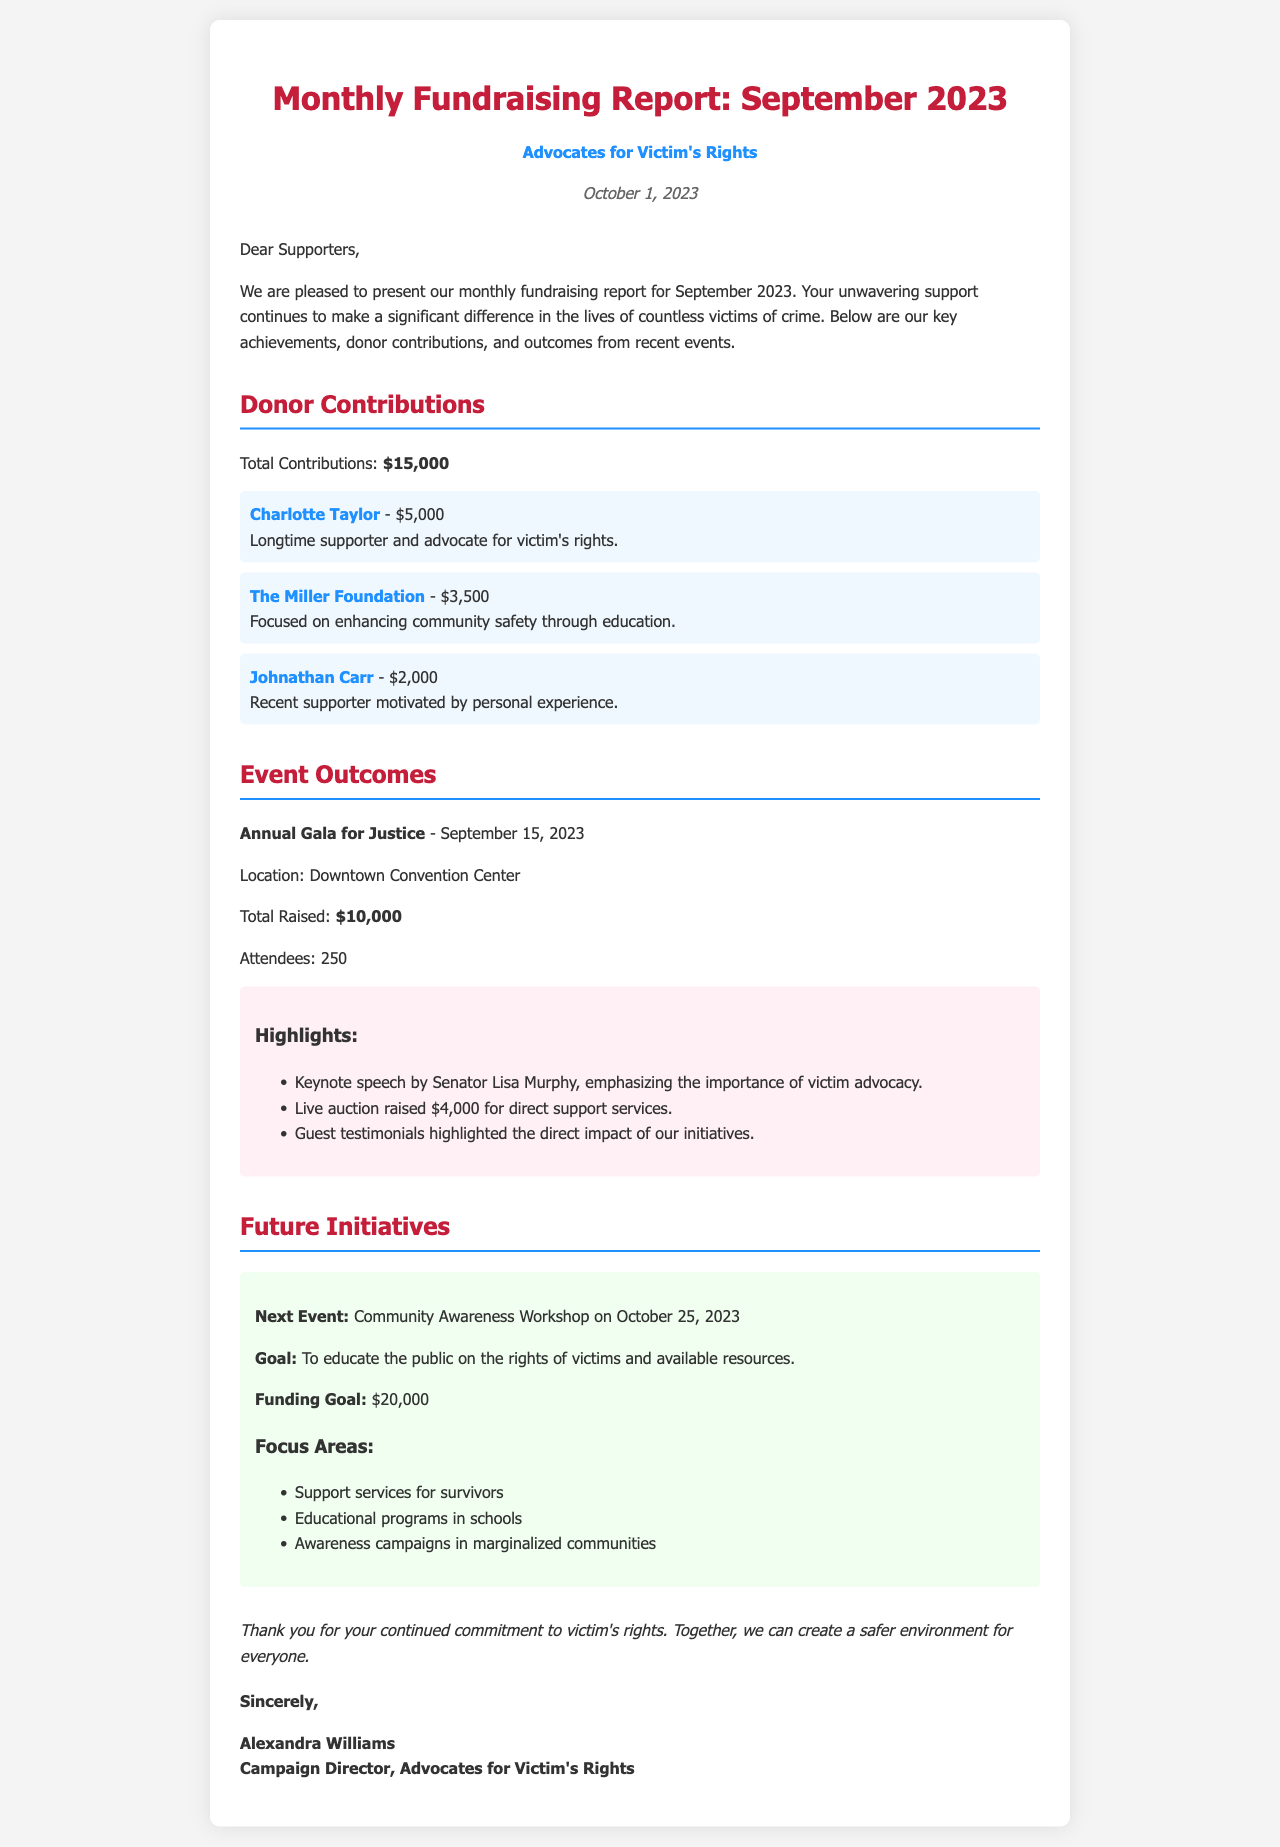What was the total contribution for September 2023? The total contribution is provided in the document as $15,000.
Answer: $15,000 Who was the keynote speaker at the Annual Gala for Justice? The keynote speaker is mentioned as Senator Lisa Murphy in the event highlights.
Answer: Senator Lisa Murphy What is the funding goal for the Community Awareness Workshop? The funding goal is specified as $20,000 in the future initiatives section.
Answer: $20,000 How many attendees were present at the Annual Gala for Justice? The document states that there were 250 attendees at the event.
Answer: 250 What date is the Community Awareness Workshop scheduled for? The date for the workshop is mentioned as October 25, 2023.
Answer: October 25, 2023 Which donor contributed the highest amount? The highest contributing donor listed is Charlotte Taylor with $5,000.
Answer: Charlotte Taylor What is the total amount raised during the Annual Gala for Justice? The total raised during the gala is highlighted as $10,000.
Answer: $10,000 What is one of the focus areas for future initiatives? The document lists support services for survivors as one of the focus areas in the future initiatives section.
Answer: Support services for survivors What organization is mentioned in the report? The document identifies the organization as Advocates for Victim's Rights.
Answer: Advocates for Victim's Rights 